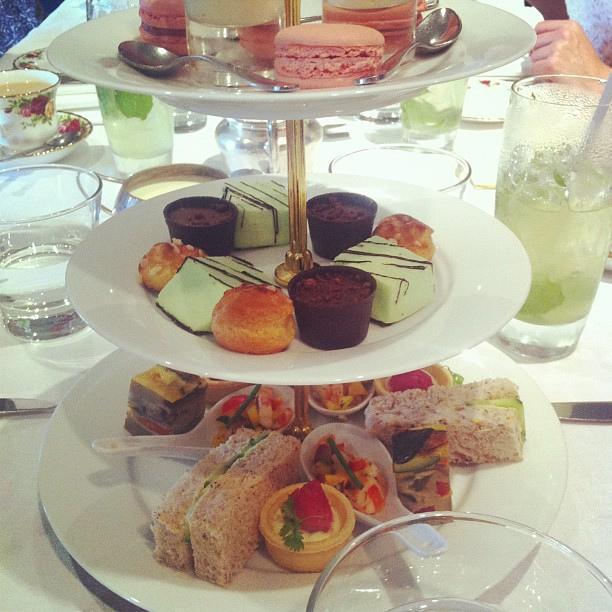How many plates are in this photo?
Give a very brief answer. 3. How many spoons are in the picture?
Give a very brief answer. 4. How many bowls are in the picture?
Give a very brief answer. 1. How many cakes are visible?
Give a very brief answer. 9. How many sandwiches are there?
Give a very brief answer. 3. How many cups can you see?
Give a very brief answer. 6. 